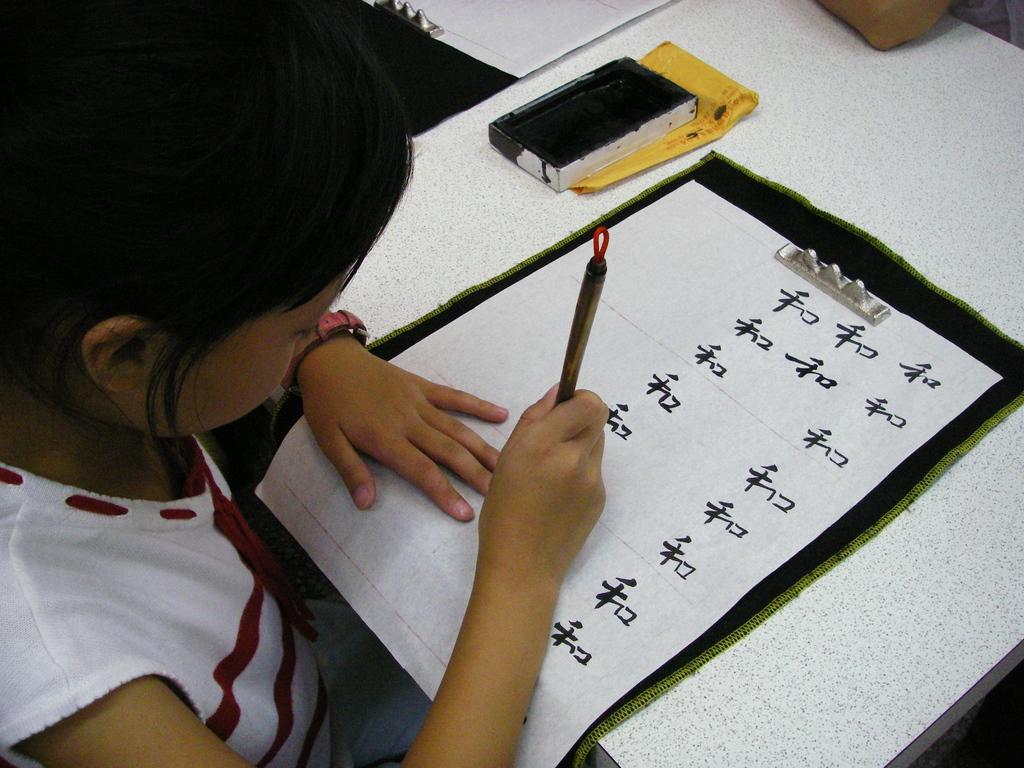Can you describe this image briefly? In this picture we can see a kid, paper, table and other objects. 